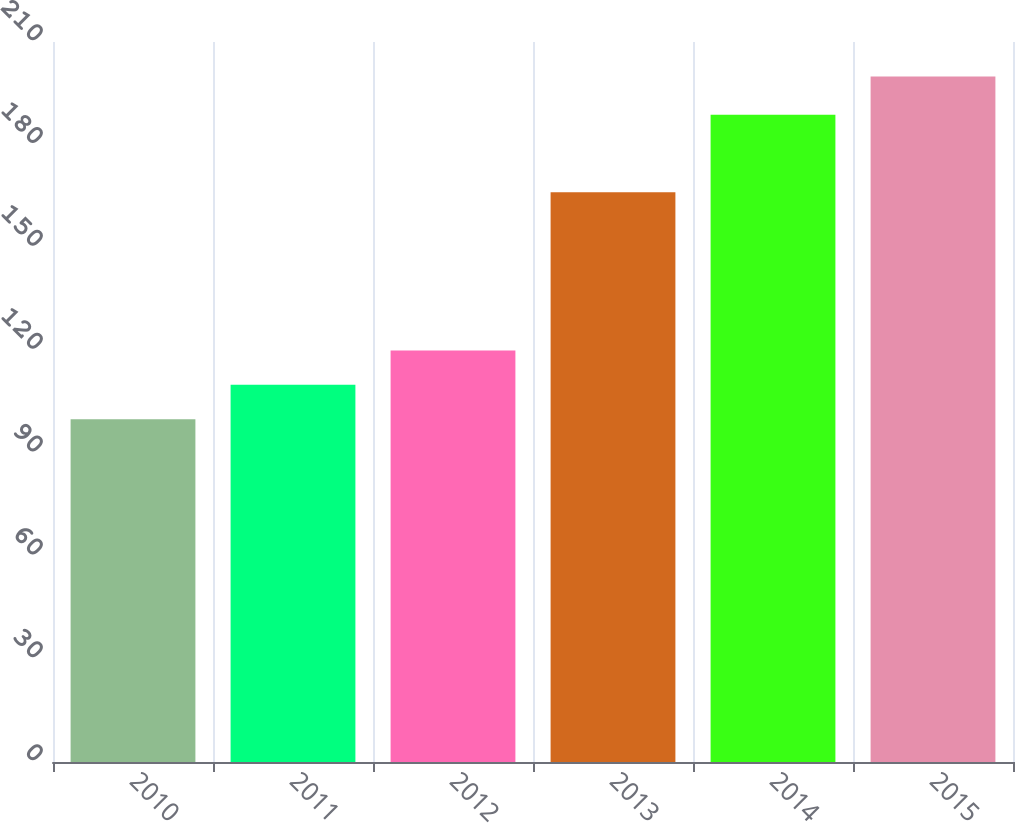Convert chart to OTSL. <chart><loc_0><loc_0><loc_500><loc_500><bar_chart><fcel>2010<fcel>2011<fcel>2012<fcel>2013<fcel>2014<fcel>2015<nl><fcel>100<fcel>110<fcel>120<fcel>166.19<fcel>188.78<fcel>199.95<nl></chart> 